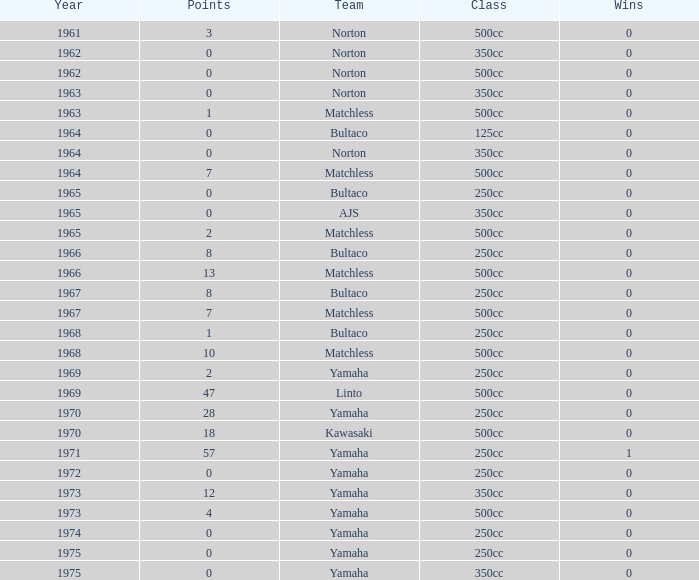What is the average wins in 250cc class for Bultaco with 8 points later than 1966? 0.0. 